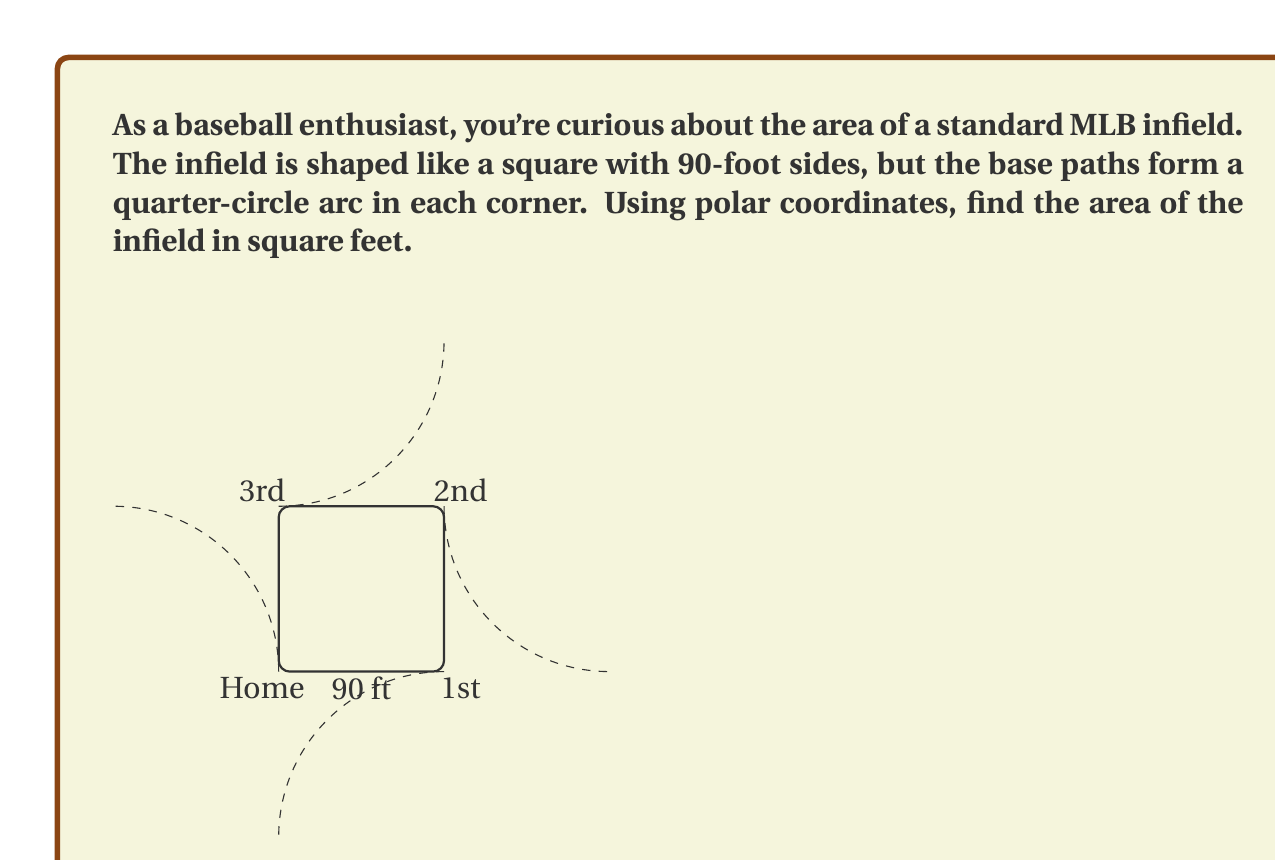Help me with this question. Let's approach this step-by-step:

1) The infield is symmetric, so we can focus on one quarter and multiply the result by 4.

2) Each quarter consists of a square corner (45 ft × 45 ft) and a quarter-circle arc.

3) The area of the square corner is easy: $45 \times 45 = 2025$ sq ft.

4) For the quarter-circle, we'll use polar coordinates. The equation of a circle with radius 90 ft is $r = 90$.

5) The area of a region in polar coordinates is given by:

   $$A = \frac{1}{2} \int_{\theta_1}^{\theta_2} r^2 d\theta$$

6) For our quarter-circle, $\theta$ goes from 0 to $\frac{\pi}{2}$, and $r = 90$:

   $$A_{quarter-circle} = \frac{1}{2} \int_{0}^{\frac{\pi}{2}} 90^2 d\theta$$

7) Evaluating the integral:

   $$A_{quarter-circle} = \frac{1}{2} \times 90^2 \times \theta \Big|_{0}^{\frac{\pi}{2}} = \frac{1}{2} \times 8100 \times \frac{\pi}{2} = 2025\pi$$

8) The total area of one quarter is:

   $A_{quarter} = 2025 + 2025\pi$

9) For the entire infield, multiply by 4:

   $A_{infield} = 4(2025 + 2025\pi) = 8100 + 8100\pi$
Answer: $8100 + 8100\pi$ square feet 